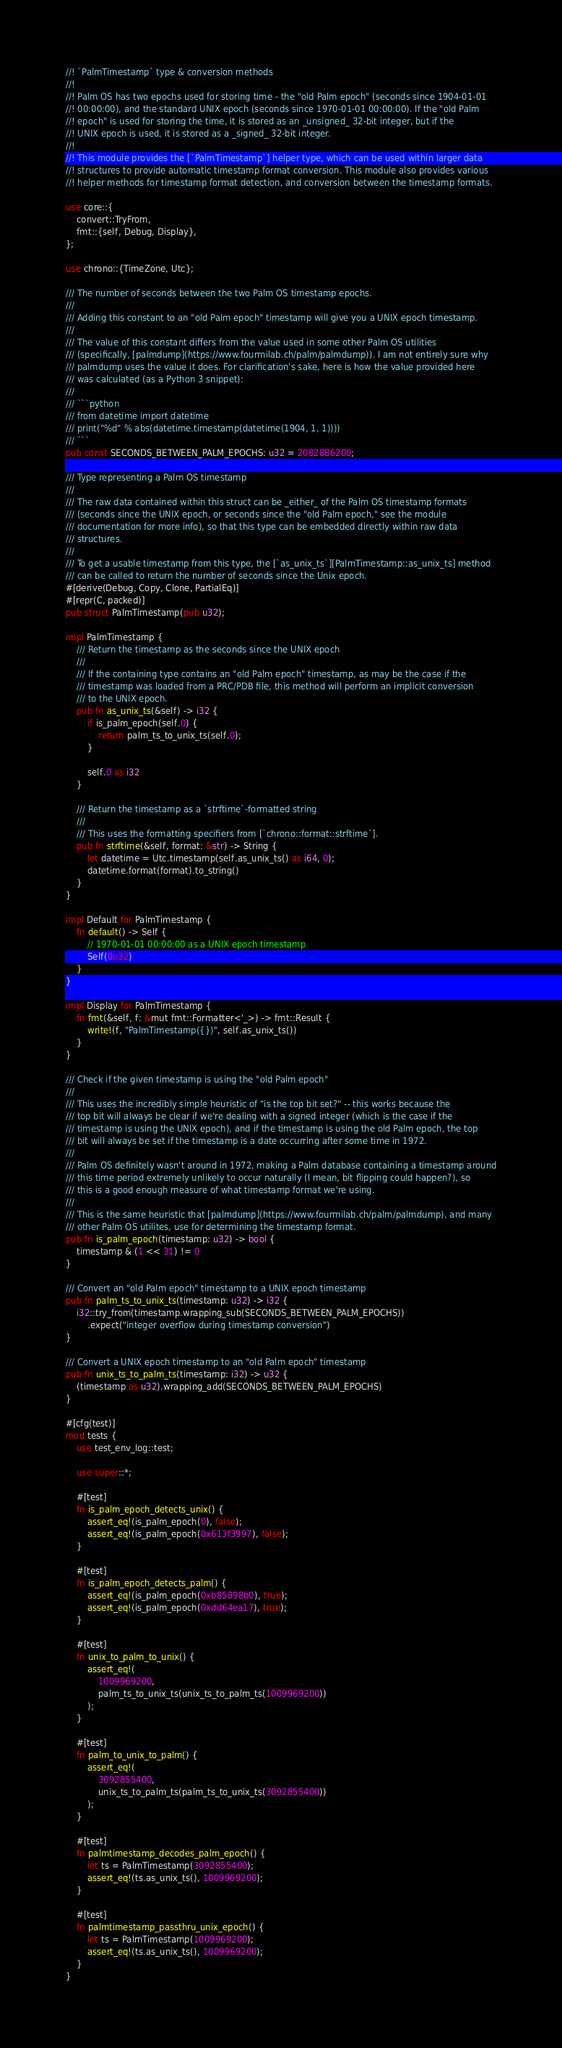<code> <loc_0><loc_0><loc_500><loc_500><_Rust_>//! `PalmTimestamp` type & conversion methods
//!
//! Palm OS has two epochs used for storing time - the "old Palm epoch" (seconds since 1904-01-01
//! 00:00:00), and the standard UNIX epoch (seconds since 1970-01-01 00:00:00). If the "old Palm
//! epoch" is used for storing the time, it is stored as an _unsigned_ 32-bit integer, but if the
//! UNIX epoch is used, it is stored as a _signed_ 32-bit integer.
//!
//! This module provides the [`PalmTimestamp`] helper type, which can be used within larger data
//! structures to provide automatic timestamp format conversion. This module also provides various
//! helper methods for timestamp format detection, and conversion between the timestamp formats.

use core::{
	convert::TryFrom,
	fmt::{self, Debug, Display},
};

use chrono::{TimeZone, Utc};

/// The number of seconds between the two Palm OS timestamp epochs.
///
/// Adding this constant to an "old Palm epoch" timestamp will give you a UNIX epoch timestamp.
///
/// The value of this constant differs from the value used in some other Palm OS utilities
/// (specifically, [palmdump](https://www.fourmilab.ch/palm/palmdump)). I am not entirely sure why
/// palmdump uses the value it does. For clarification's sake, here is how the value provided here
/// was calculated (as a Python 3 snippet):
///
/// ```python
/// from datetime import datetime
/// print("%d" % abs(datetime.timestamp(datetime(1904, 1, 1))))
/// ```
pub const SECONDS_BETWEEN_PALM_EPOCHS: u32 = 2082886200;

/// Type representing a Palm OS timestamp
///
/// The raw data contained within this struct can be _either_ of the Palm OS timestamp formats
/// (seconds since the UNIX epoch, or seconds since the "old Palm epoch," see the module
/// documentation for more info), so that this type can be embedded directly within raw data
/// structures.
///
/// To get a usable timestamp from this type, the [`as_unix_ts`][PalmTimestamp::as_unix_ts] method
/// can be called to return the number of seconds since the Unix epoch.
#[derive(Debug, Copy, Clone, PartialEq)]
#[repr(C, packed)]
pub struct PalmTimestamp(pub u32);

impl PalmTimestamp {
	/// Return the timestamp as the seconds since the UNIX epoch
	///
	/// If the containing type contains an "old Palm epoch" timestamp, as may be the case if the
	/// timestamp was loaded from a PRC/PDB file, this method will perform an implicit conversion
	/// to the UNIX epoch.
	pub fn as_unix_ts(&self) -> i32 {
		if is_palm_epoch(self.0) {
			return palm_ts_to_unix_ts(self.0);
		}

		self.0 as i32
	}

	/// Return the timestamp as a `strftime`-formatted string
	///
	/// This uses the formatting specifiers from [`chrono::format::strftime`].
	pub fn strftime(&self, format: &str) -> String {
		let datetime = Utc.timestamp(self.as_unix_ts() as i64, 0);
		datetime.format(format).to_string()
	}
}

impl Default for PalmTimestamp {
	fn default() -> Self {
		// 1970-01-01 00:00:00 as a UNIX epoch timestamp
		Self(0u32)
	}
}

impl Display for PalmTimestamp {
	fn fmt(&self, f: &mut fmt::Formatter<'_>) -> fmt::Result {
		write!(f, "PalmTimestamp({})", self.as_unix_ts())
	}
}

/// Check if the given timestamp is using the "old Palm epoch"
///
/// This uses the incredibly simple heuristic of "is the top bit set?" -- this works because the
/// top bit will always be clear if we're dealing with a signed integer (which is the case if the
/// timestamp is using the UNIX epoch), and if the timestamp is using the old Palm epoch, the top
/// bit will always be set if the timestamp is a date occurring after some time in 1972.
///
/// Palm OS definitely wasn't around in 1972, making a Palm database containing a timestamp around
/// this time period extremely unlikely to occur naturally (I mean, bit flipping could happen?), so
/// this is a good enough measure of what timestamp format we're using.
///
/// This is the same heuristic that [palmdump](https://www.fourmilab.ch/palm/palmdump), and many
/// other Palm OS utilites, use for determining the timestamp format.
pub fn is_palm_epoch(timestamp: u32) -> bool {
	timestamp & (1 << 31) != 0
}

/// Convert an "old Palm epoch" timestamp to a UNIX epoch timestamp
pub fn palm_ts_to_unix_ts(timestamp: u32) -> i32 {
	i32::try_from(timestamp.wrapping_sub(SECONDS_BETWEEN_PALM_EPOCHS))
		.expect("integer overflow during timestamp conversion")
}

/// Convert a UNIX epoch timestamp to an "old Palm epoch" timestamp
pub fn unix_ts_to_palm_ts(timestamp: i32) -> u32 {
	(timestamp as u32).wrapping_add(SECONDS_BETWEEN_PALM_EPOCHS)
}

#[cfg(test)]
mod tests {
	use test_env_log::test;

	use super::*;

	#[test]
	fn is_palm_epoch_detects_unix() {
		assert_eq!(is_palm_epoch(0), false);
		assert_eq!(is_palm_epoch(0x613f3997), false);
	}

	#[test]
	fn is_palm_epoch_detects_palm() {
		assert_eq!(is_palm_epoch(0xb85898b0), true);
		assert_eq!(is_palm_epoch(0xdd64ea17), true);
	}

	#[test]
	fn unix_to_palm_to_unix() {
		assert_eq!(
			1009969200,
			palm_ts_to_unix_ts(unix_ts_to_palm_ts(1009969200))
		);
	}

	#[test]
	fn palm_to_unix_to_palm() {
		assert_eq!(
			3092855400,
			unix_ts_to_palm_ts(palm_ts_to_unix_ts(3092855400))
		);
	}

	#[test]
	fn palmtimestamp_decodes_palm_epoch() {
		let ts = PalmTimestamp(3092855400);
		assert_eq!(ts.as_unix_ts(), 1009969200);
	}

	#[test]
	fn palmtimestamp_passthru_unix_epoch() {
		let ts = PalmTimestamp(1009969200);
		assert_eq!(ts.as_unix_ts(), 1009969200);
	}
}
</code> 